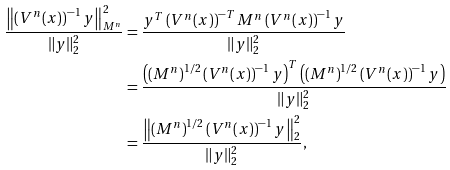Convert formula to latex. <formula><loc_0><loc_0><loc_500><loc_500>\frac { \left \| \left ( V ^ { n } ( x ) \right ) ^ { - 1 } y \right \| ^ { 2 } _ { M ^ { n } } } { \| y \| ^ { 2 } _ { 2 } } & = \frac { y ^ { T } \left ( V ^ { n } ( x ) \right ) ^ { - T } M ^ { n } \left ( V ^ { n } ( x ) \right ) ^ { - 1 } y } { \| y \| ^ { 2 } _ { 2 } } \\ & = \frac { \left ( \left ( M ^ { n } \right ) ^ { 1 / 2 } \left ( V ^ { n } ( x ) \right ) ^ { - 1 } y \right ) ^ { T } \left ( \left ( M ^ { n } \right ) ^ { 1 / 2 } \left ( V ^ { n } ( x ) \right ) ^ { - 1 } y \right ) } { \| y \| ^ { 2 } _ { 2 } } \\ & = \frac { \left \| \left ( M ^ { n } \right ) ^ { 1 / 2 } \left ( V ^ { n } ( x ) \right ) ^ { - 1 } y \right \| ^ { 2 } _ { 2 } } { \| y \| ^ { 2 } _ { 2 } } ,</formula> 